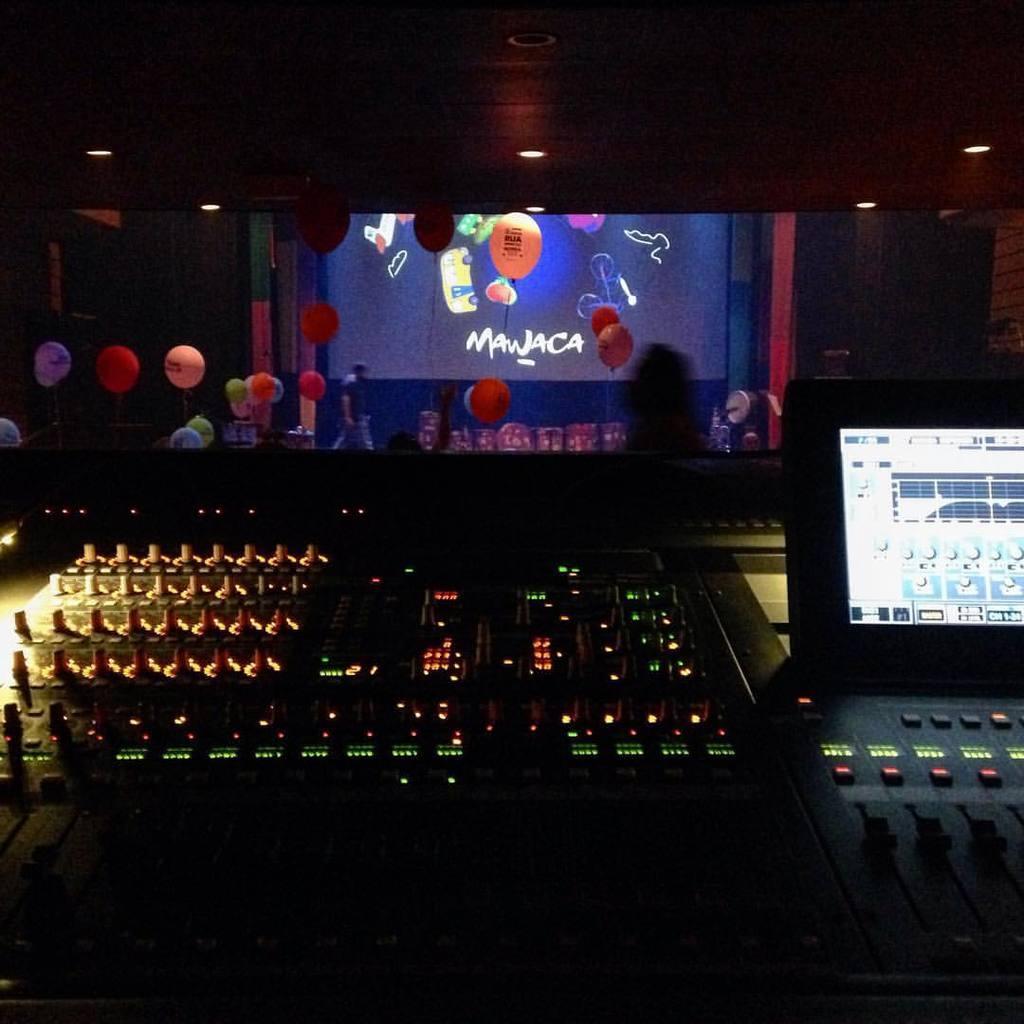In one or two sentences, can you explain what this image depicts? In this picture we can see devices, balloons, screen, lights, walls, some people and some objects. 